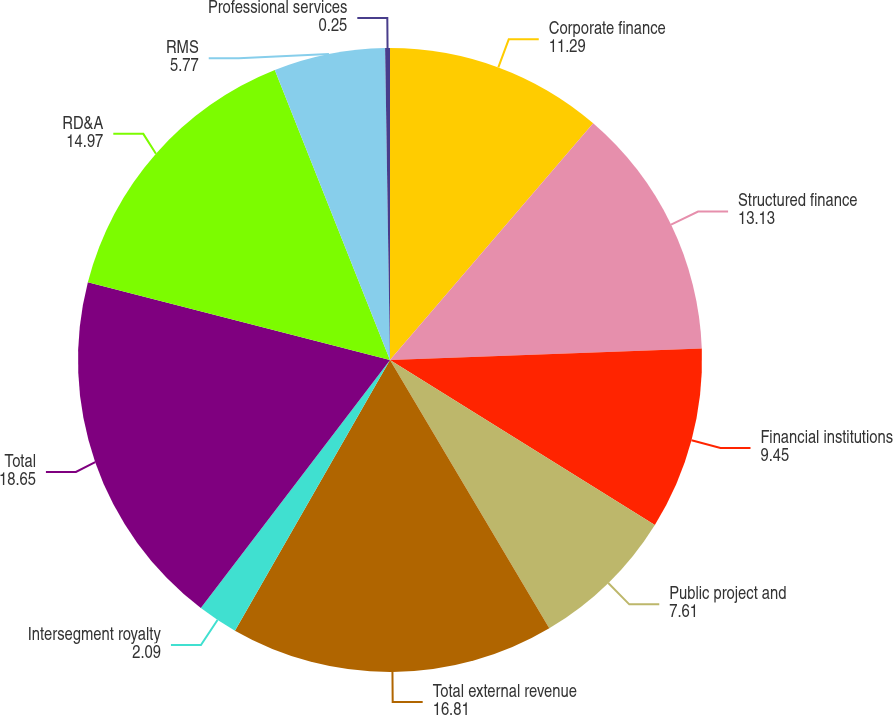Convert chart to OTSL. <chart><loc_0><loc_0><loc_500><loc_500><pie_chart><fcel>Corporate finance<fcel>Structured finance<fcel>Financial institutions<fcel>Public project and<fcel>Total external revenue<fcel>Intersegment royalty<fcel>Total<fcel>RD&A<fcel>RMS<fcel>Professional services<nl><fcel>11.29%<fcel>13.13%<fcel>9.45%<fcel>7.61%<fcel>16.81%<fcel>2.09%<fcel>18.65%<fcel>14.97%<fcel>5.77%<fcel>0.25%<nl></chart> 